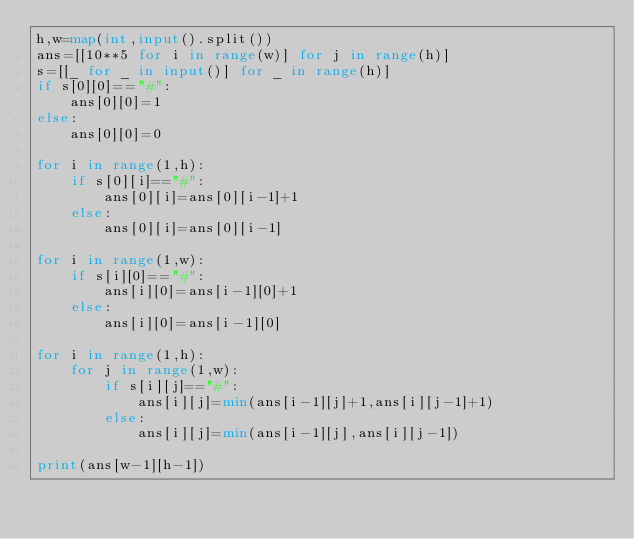<code> <loc_0><loc_0><loc_500><loc_500><_Python_>h,w=map(int,input().split())
ans=[[10**5 for i in range(w)] for j in range(h)]
s=[[_ for _ in input()] for _ in range(h)]
if s[0][0]=="#":
    ans[0][0]=1
else:
    ans[0][0]=0

for i in range(1,h):
    if s[0][i]=="#":
        ans[0][i]=ans[0][i-1]+1
    else:
        ans[0][i]=ans[0][i-1]

for i in range(1,w):
    if s[i][0]=="#":
        ans[i][0]=ans[i-1][0]+1
    else:
        ans[i][0]=ans[i-1][0]

for i in range(1,h):
    for j in range(1,w):
        if s[i][j]=="#":
            ans[i][j]=min(ans[i-1][j]+1,ans[i][j-1]+1)
        else:
            ans[i][j]=min(ans[i-1][j],ans[i][j-1])

print(ans[w-1][h-1])</code> 